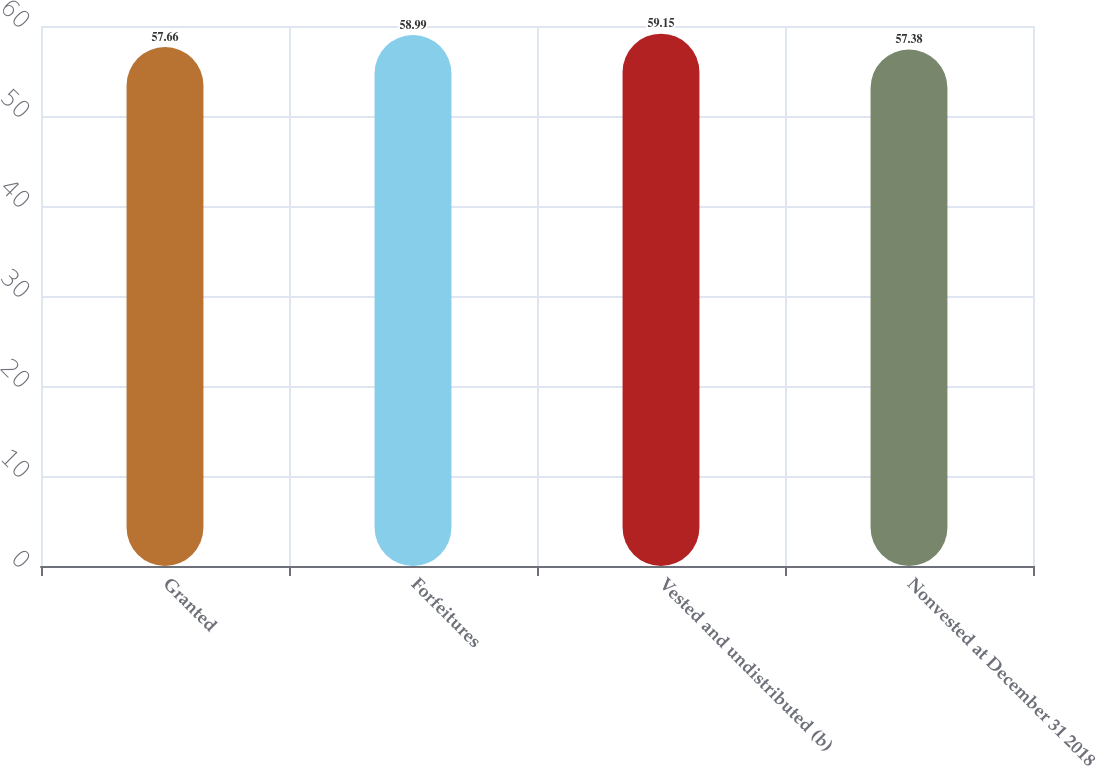Convert chart to OTSL. <chart><loc_0><loc_0><loc_500><loc_500><bar_chart><fcel>Granted<fcel>Forfeitures<fcel>Vested and undistributed (b)<fcel>Nonvested at December 31 2018<nl><fcel>57.66<fcel>58.99<fcel>59.15<fcel>57.38<nl></chart> 